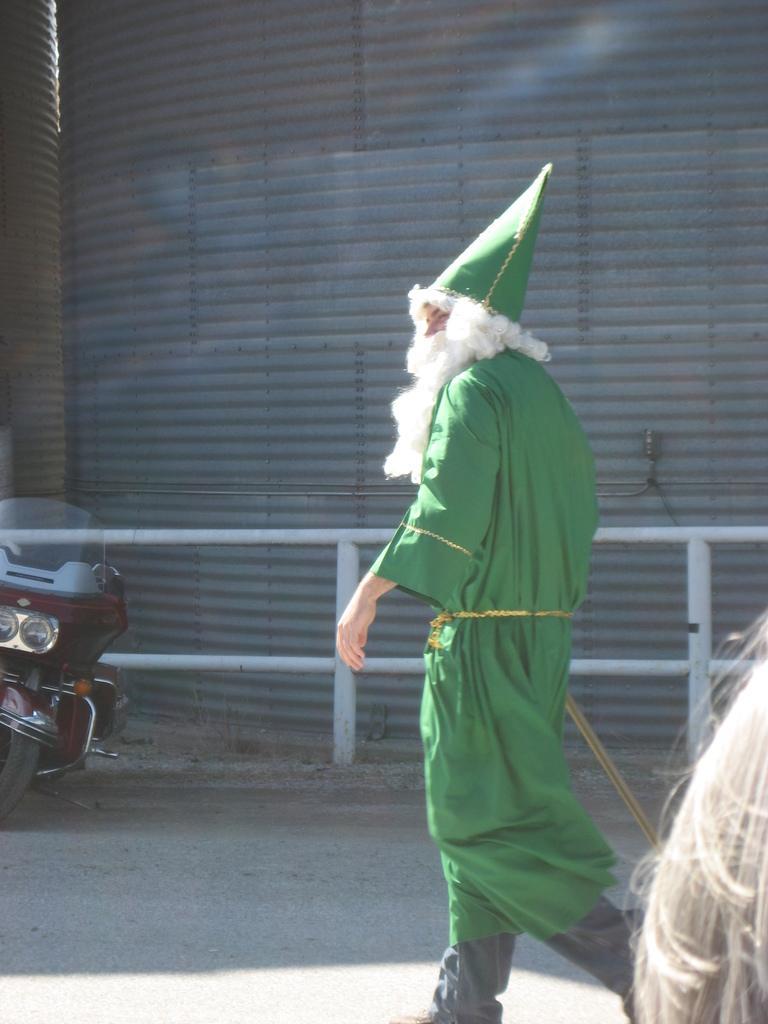Could you give a brief overview of what you see in this image? This picture might be taken from outside of the city and it is sunny. In this image, on the right corner, we can see hair of a person. In the middle of the image, we can see a person wearing green color dress is walking on the road. On the left side, we can see a bike. In the background, we can see a metal rod and a metal wall. 